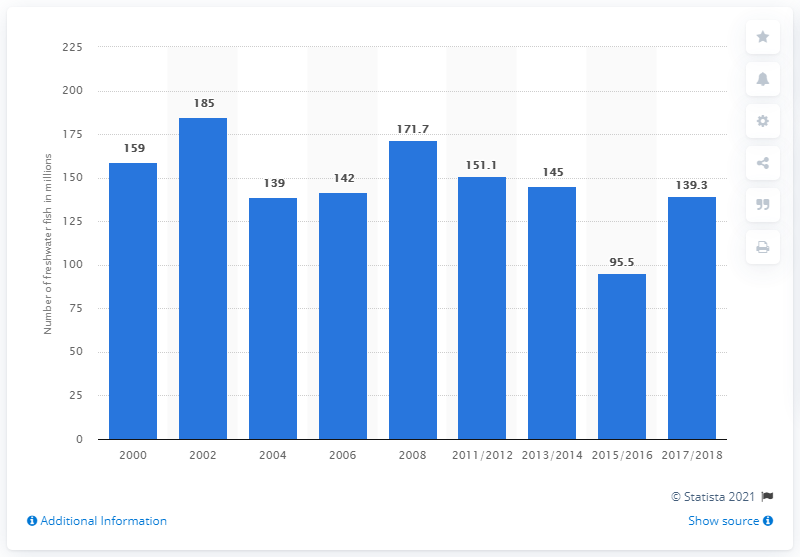Specify some key components in this picture. In the United States in 2017/2018, an estimated 139.3 million freshwater fish were owned by households. 